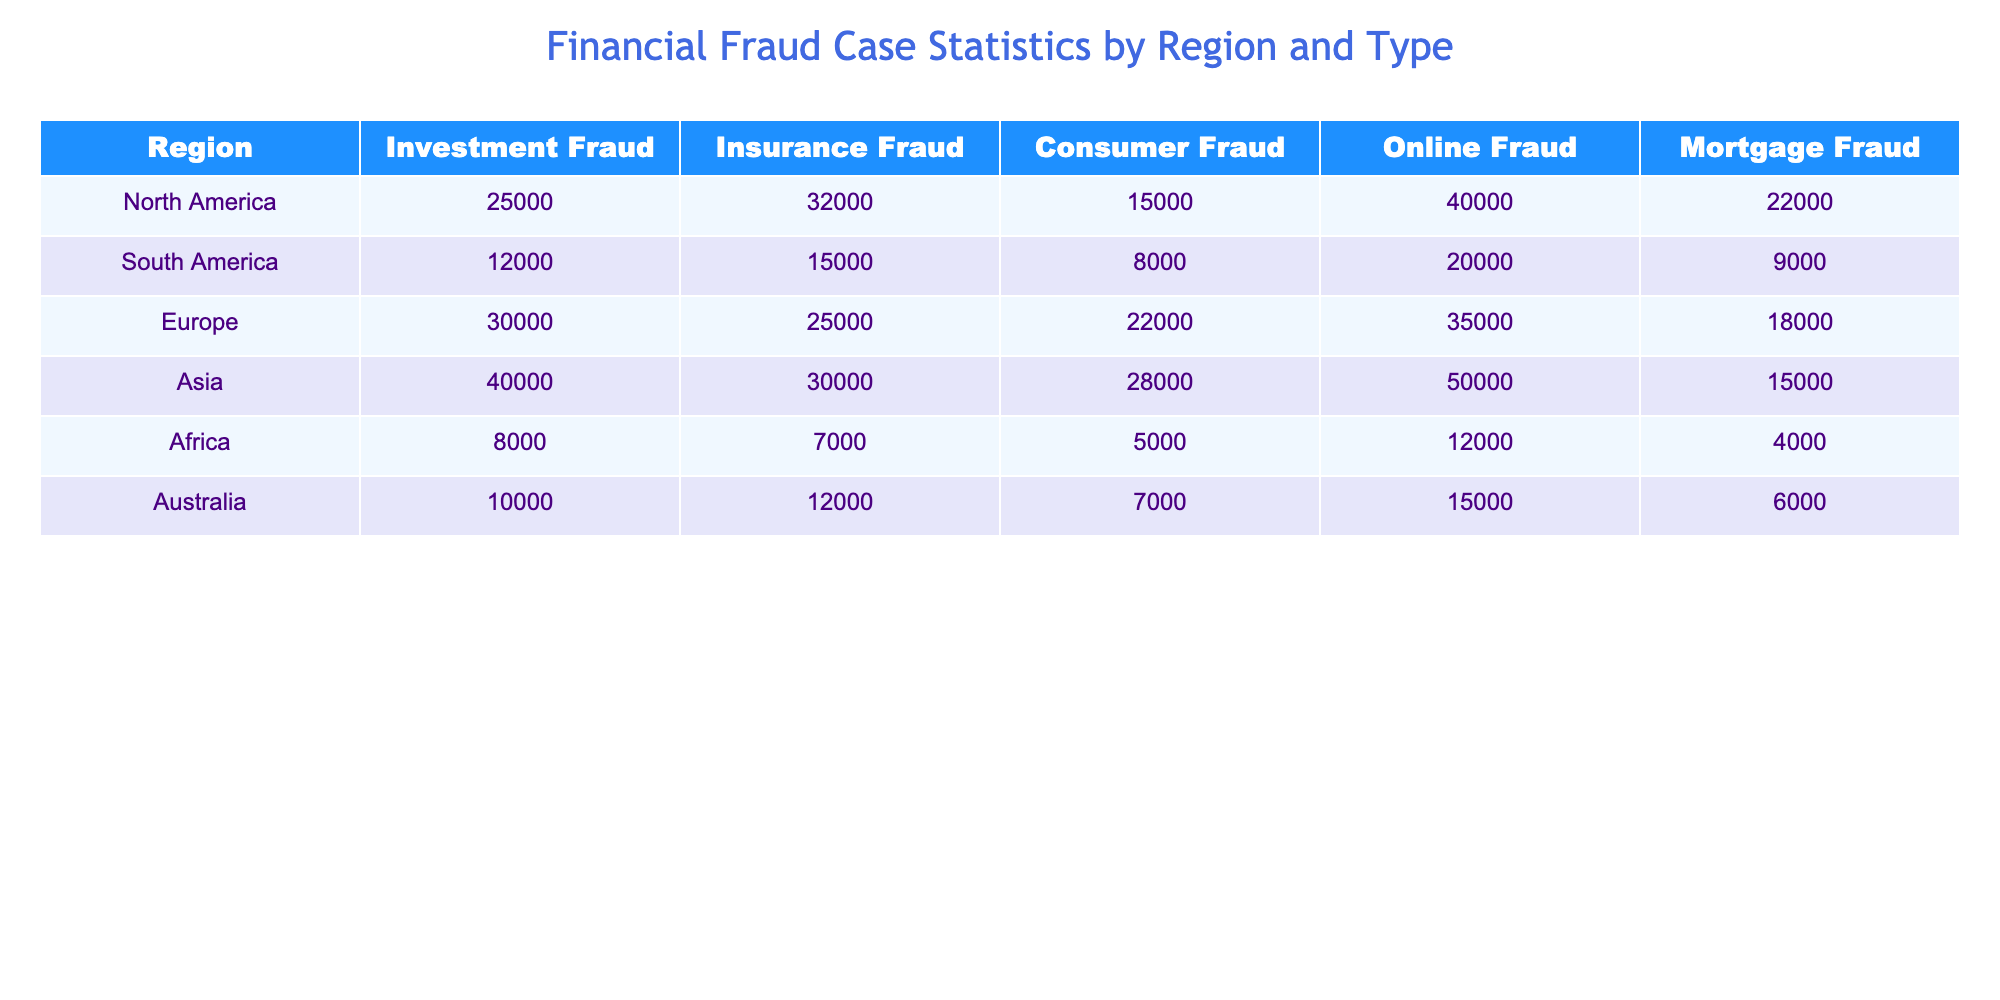What region has the highest number of investment fraud cases? By examining the "Investment Fraud" column, we can see that Asia has the highest value, which is 40,000 cases.
Answer: Asia What is the total number of online fraud cases across all regions? Adding the values in the "Online Fraud" column: 40,000 (North America) + 20,000 (South America) + 35,000 (Europe) + 50,000 (Asia) + 12,000 (Africa) + 15,000 (Australia) equals 172,000 cases.
Answer: 172,000 Is there more consumer fraud in North America than in Africa? In North America, the number of consumer fraud cases is 15,000, while in Africa, it is only 5,000. Therefore, it is true that North America has more consumer fraud cases.
Answer: Yes Which region has the smallest total amount of fraud cases across all types? To find this, we sum the values for each region: North America (125,000), South America (63,000), Europe (122,000), Asia (140,000), Africa (38,000), Australia (42,000). Africa has the smallest total with 38,000 cases.
Answer: Africa What is the difference in the number of mortgage fraud cases between Europe and South America? The number of mortgage fraud cases in Europe is 18,000, while in South America, it is 9,000. The difference is 18,000 - 9,000 = 9,000 cases.
Answer: 9,000 Which type of fraud is most prevalent in Australia? Looking at the values for Australia: Investment Fraud (10,000), Insurance Fraud (12,000), Consumer Fraud (7,000), Online Fraud (15,000), Mortgage Fraud (6,000), Online Fraud has the highest value at 15,000.
Answer: Online Fraud If you sum the investment and mortgage fraud cases across North America, what total do you get? The investment fraud cases in North America are 25,000 and the mortgage fraud cases are 22,000. Adding these gives 25,000 + 22,000 = 47,000 cases.
Answer: 47,000 Is the total number of insurance fraud cases in Europe greater than the total number of investment fraud cases in South America? The total number of insurance fraud cases in Europe is 25,000, while the investment fraud cases in South America are 12,000. Since 25,000 is greater than 12,000, the statement is true.
Answer: Yes What percentage of total fraud cases do mortgage fraud cases represent in Asia? First, we calculate the total fraud cases in Asia: 40,000 (Investment) + 30,000 (Insurance) + 28,000 (Consumer) + 50,000 (Online) + 15,000 (Mortgage) = 163,000 cases. Mortgage fraud cases are 15,000. So, the percentage is (15,000 / 163,000) * 100 ≈ 9.2%.
Answer: 9.2% Which region has the highest number of consumer fraud cases? From the "Consumer Fraud" column, North America has 15,000, South America has 8,000, Europe has 22,000, Asia has 28,000, Africa has 5,000, and Australia has 7,000. Asia has the most with 28,000 cases.
Answer: Asia 